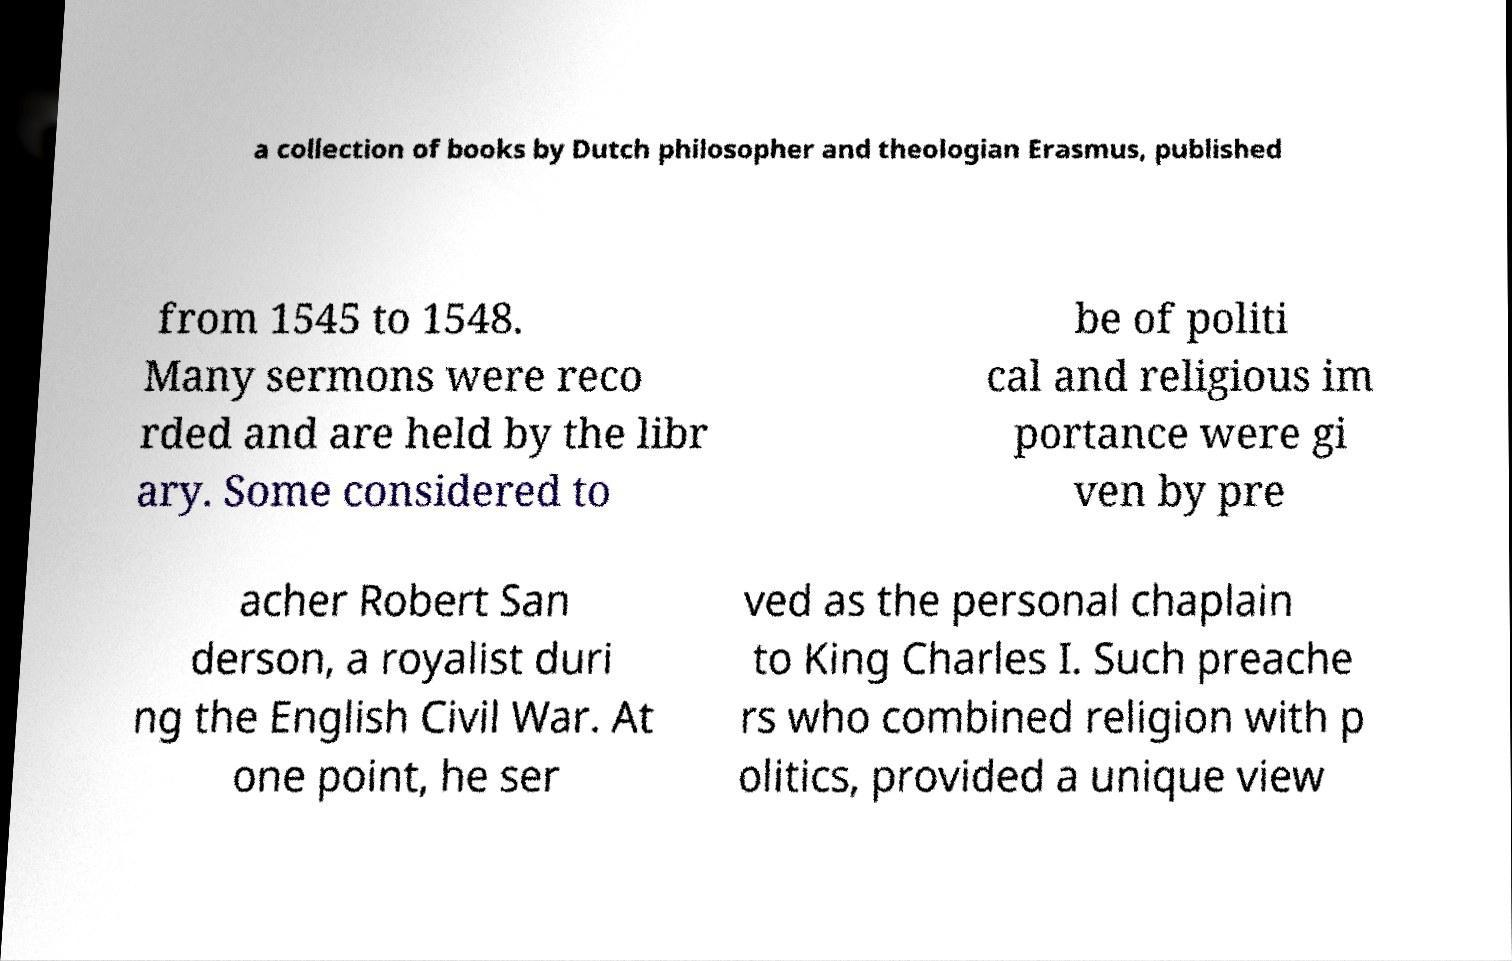Can you read and provide the text displayed in the image?This photo seems to have some interesting text. Can you extract and type it out for me? a collection of books by Dutch philosopher and theologian Erasmus, published from 1545 to 1548. Many sermons were reco rded and are held by the libr ary. Some considered to be of politi cal and religious im portance were gi ven by pre acher Robert San derson, a royalist duri ng the English Civil War. At one point, he ser ved as the personal chaplain to King Charles I. Such preache rs who combined religion with p olitics, provided a unique view 